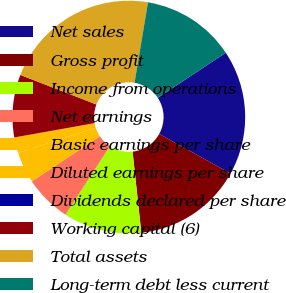Convert chart. <chart><loc_0><loc_0><loc_500><loc_500><pie_chart><fcel>Net sales<fcel>Gross profit<fcel>Income from operations<fcel>Net earnings<fcel>Basic earnings per share<fcel>Diluted earnings per share<fcel>Dividends declared per share<fcel>Working capital (6)<fcel>Total assets<fcel>Long-term debt less current<nl><fcel>17.39%<fcel>15.22%<fcel>10.87%<fcel>6.52%<fcel>4.35%<fcel>2.17%<fcel>0.0%<fcel>8.7%<fcel>21.74%<fcel>13.04%<nl></chart> 